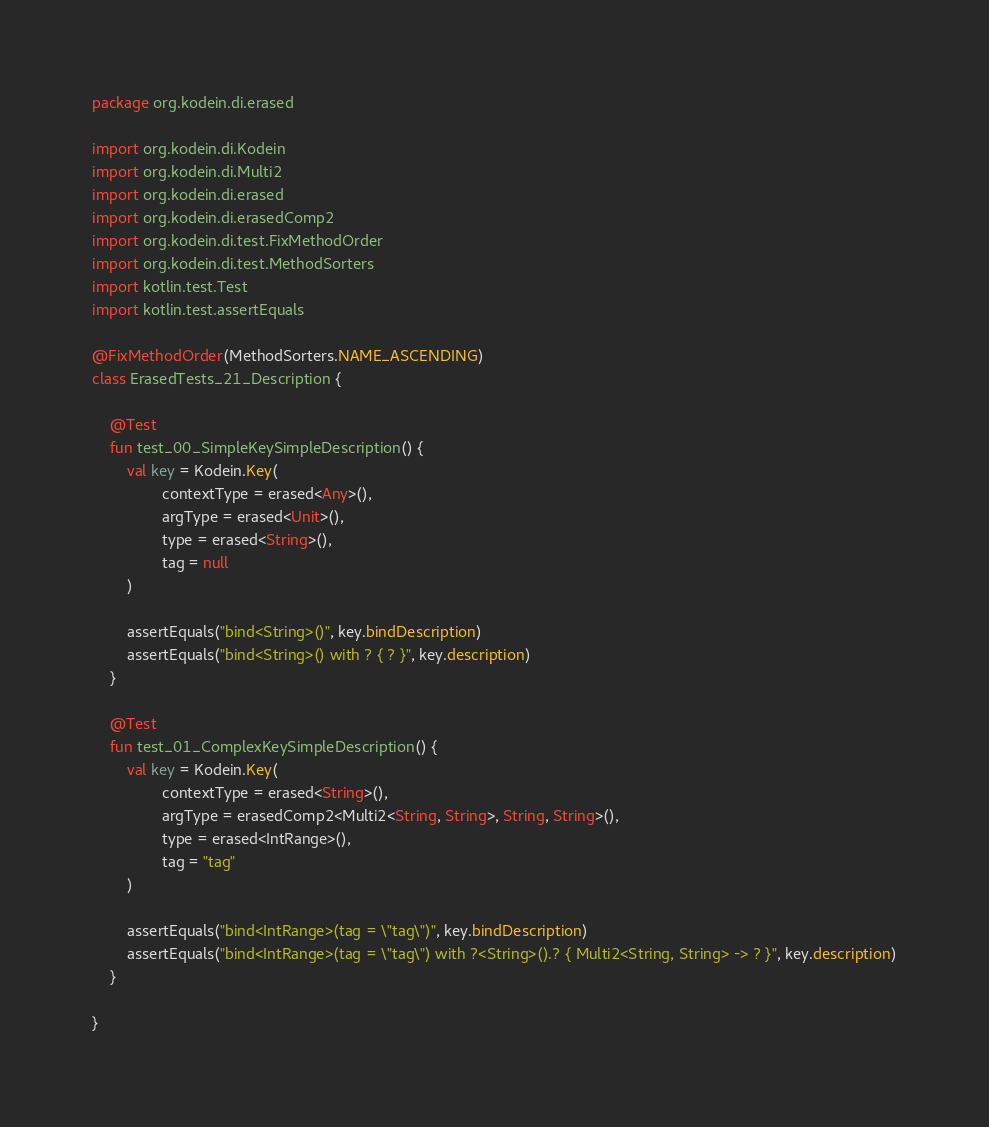Convert code to text. <code><loc_0><loc_0><loc_500><loc_500><_Kotlin_>package org.kodein.di.erased

import org.kodein.di.Kodein
import org.kodein.di.Multi2
import org.kodein.di.erased
import org.kodein.di.erasedComp2
import org.kodein.di.test.FixMethodOrder
import org.kodein.di.test.MethodSorters
import kotlin.test.Test
import kotlin.test.assertEquals

@FixMethodOrder(MethodSorters.NAME_ASCENDING)
class ErasedTests_21_Description {

    @Test
    fun test_00_SimpleKeySimpleDescription() {
        val key = Kodein.Key(
                contextType = erased<Any>(),
                argType = erased<Unit>(),
                type = erased<String>(),
                tag = null
        )

        assertEquals("bind<String>()", key.bindDescription)
        assertEquals("bind<String>() with ? { ? }", key.description)
    }

    @Test
    fun test_01_ComplexKeySimpleDescription() {
        val key = Kodein.Key(
                contextType = erased<String>(),
                argType = erasedComp2<Multi2<String, String>, String, String>(),
                type = erased<IntRange>(),
                tag = "tag"
        )

        assertEquals("bind<IntRange>(tag = \"tag\")", key.bindDescription)
        assertEquals("bind<IntRange>(tag = \"tag\") with ?<String>().? { Multi2<String, String> -> ? }", key.description)
    }

}
</code> 